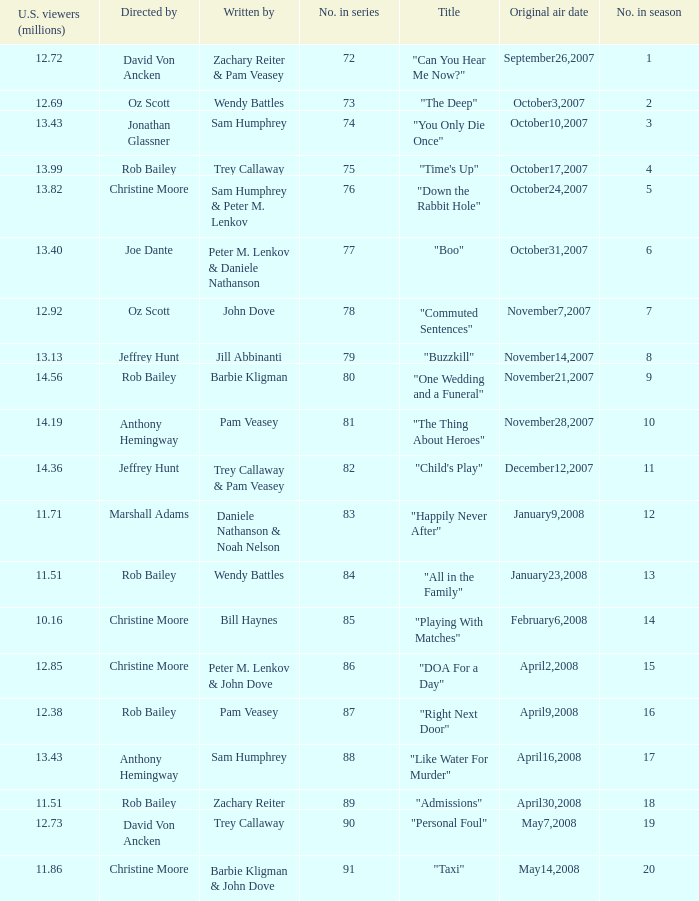How many millions of U.S. viewers watched the episode directed by Rob Bailey and written by Pam Veasey? 12.38. 